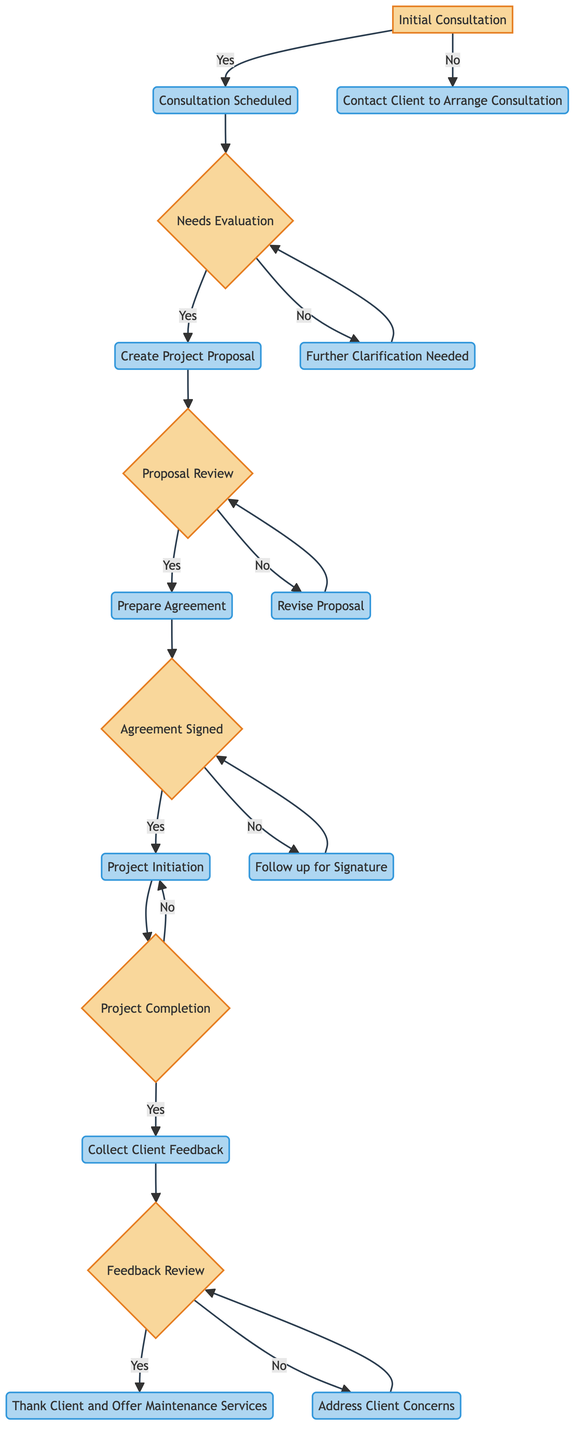What is the first decision point in the diagram? The first decision point is labeled "Is the client consultation scheduled?" This is where the decision-making process begins regarding client consultations.
Answer: Is the client consultation scheduled? What action follows "Consultation Scheduled"? After reaching the "Consultation Scheduled" point, the action taken is to "Meet with client to understand needs and gather requirements." This action occurs if the consultation has been successfully scheduled.
Answer: Meet with client to understand needs and gather requirements How many processes are there in total? By counting all the nodes specifically labeled as processes in the diagram, we find there are eight processes: "Consultation Scheduled," "Further Clarification Needed," "Create Project Proposal," "Revise Proposal," "Prepare Agreement," "Project Initiation," "Collect Client Feedback," and "Thank Client and Offer Maintenance Services." The total is eight.
Answer: Eight What happens if the project is not completed? If the project is not completed, the flow continues back to "Continue with Project Execution" which indicates that work on the project persists until it is completed.
Answer: Continue with Project Execution After the proposal is reviewed, what are the possible outcomes? Following the "Proposal Review," there are two possible outcomes: if approved, it moves on to "Prepare Agreement," and if not approved, it leads to "Revise Proposal." This bifurcation indicates the steps taken depending on the client's approval of the proposal.
Answer: Prepare Agreement or Revise Proposal What is the final step in the client consultation workflow if the client is satisfied? If the client is satisfied after feedback review, the final step is to "Thank Client and Offer Maintenance Services." This step represents the conclusion of the consultation process with gratitude expressed and services promoted.
Answer: Thank Client and Offer Maintenance Services What does the decision point "Has the client signed the agreement?" lead to if the answer is no? If the answer to "Has the client signed the agreement?" is no, the process leads to "Follow up for Signature," which indicates that action is required to obtain the necessary client signature on the agreement before proceeding.
Answer: Follow up for Signature What indication is there that further clarification is needed? The indication that further clarification is necessary comes from the decision point asking "Are the client's needs clear and feasible?" A negative answer leads to the process "Further Clarification Needed," which suggests that additional meetings are required to define the client's needs better.
Answer: Further Clarification Needed 